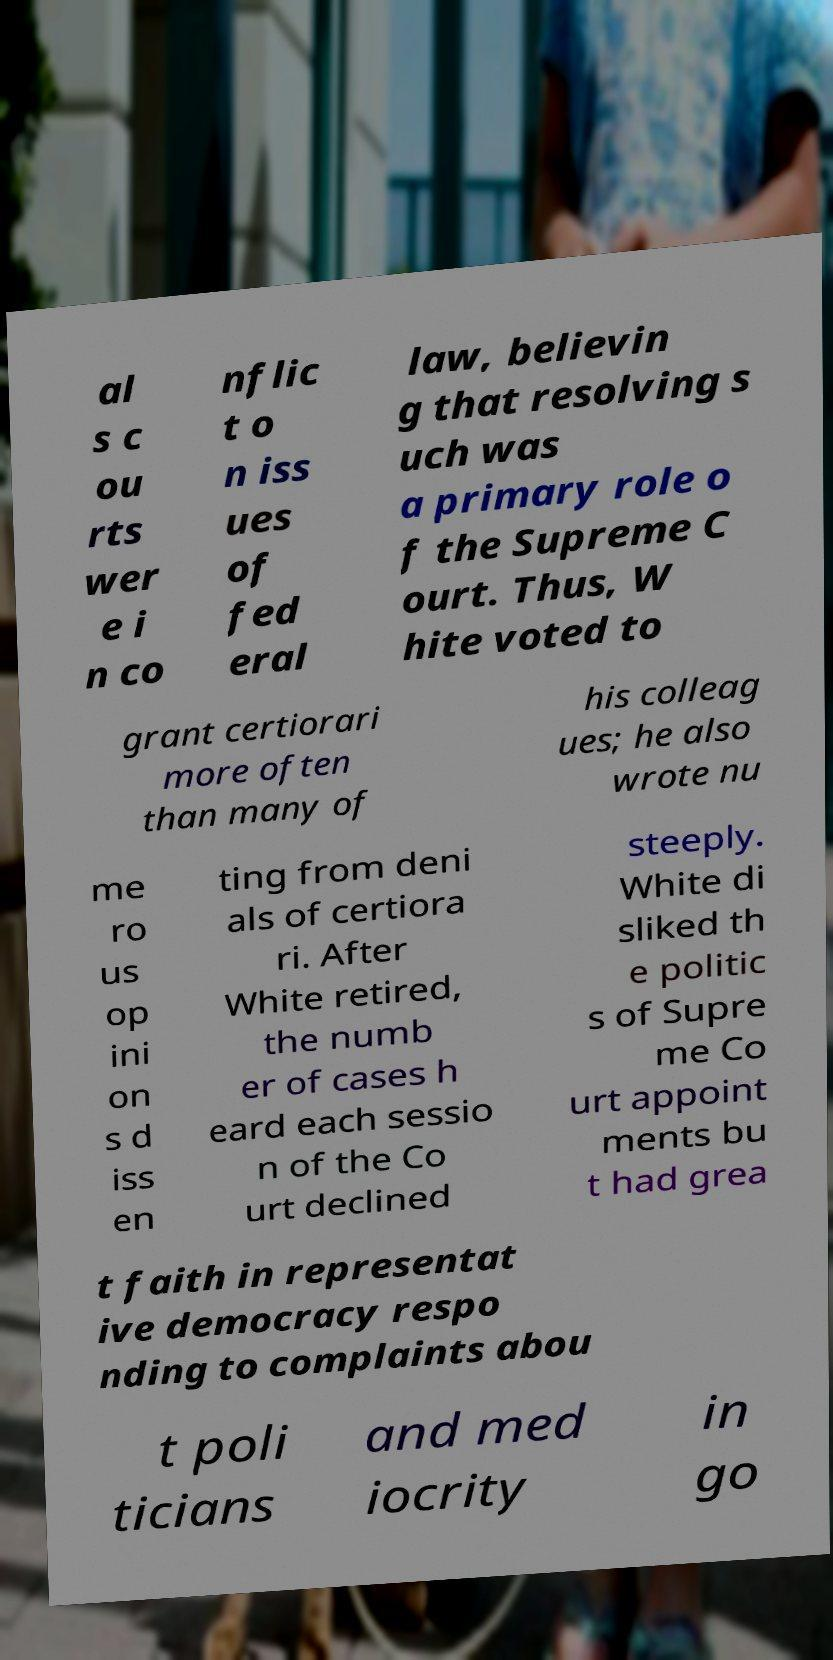Please identify and transcribe the text found in this image. al s c ou rts wer e i n co nflic t o n iss ues of fed eral law, believin g that resolving s uch was a primary role o f the Supreme C ourt. Thus, W hite voted to grant certiorari more often than many of his colleag ues; he also wrote nu me ro us op ini on s d iss en ting from deni als of certiora ri. After White retired, the numb er of cases h eard each sessio n of the Co urt declined steeply. White di sliked th e politic s of Supre me Co urt appoint ments bu t had grea t faith in representat ive democracy respo nding to complaints abou t poli ticians and med iocrity in go 